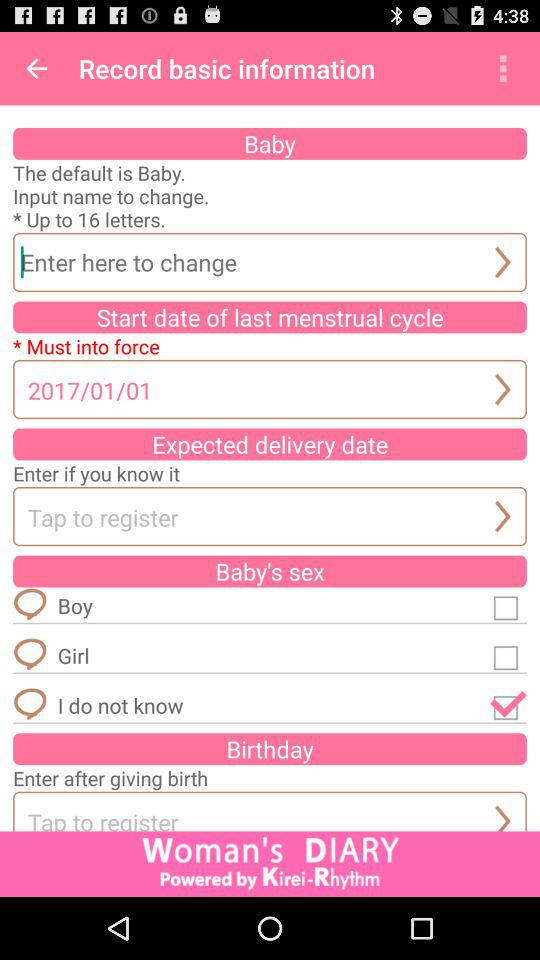What is the status of "Girl"? The status is off. 